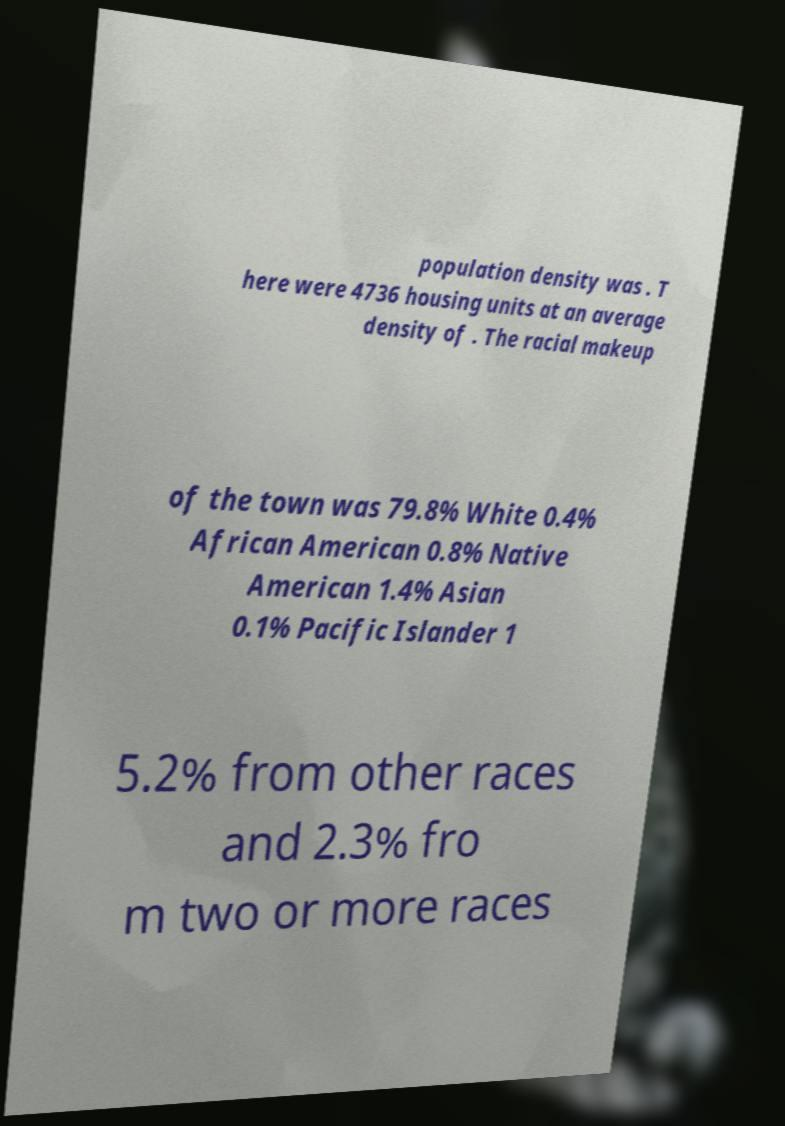Can you read and provide the text displayed in the image?This photo seems to have some interesting text. Can you extract and type it out for me? population density was . T here were 4736 housing units at an average density of . The racial makeup of the town was 79.8% White 0.4% African American 0.8% Native American 1.4% Asian 0.1% Pacific Islander 1 5.2% from other races and 2.3% fro m two or more races 